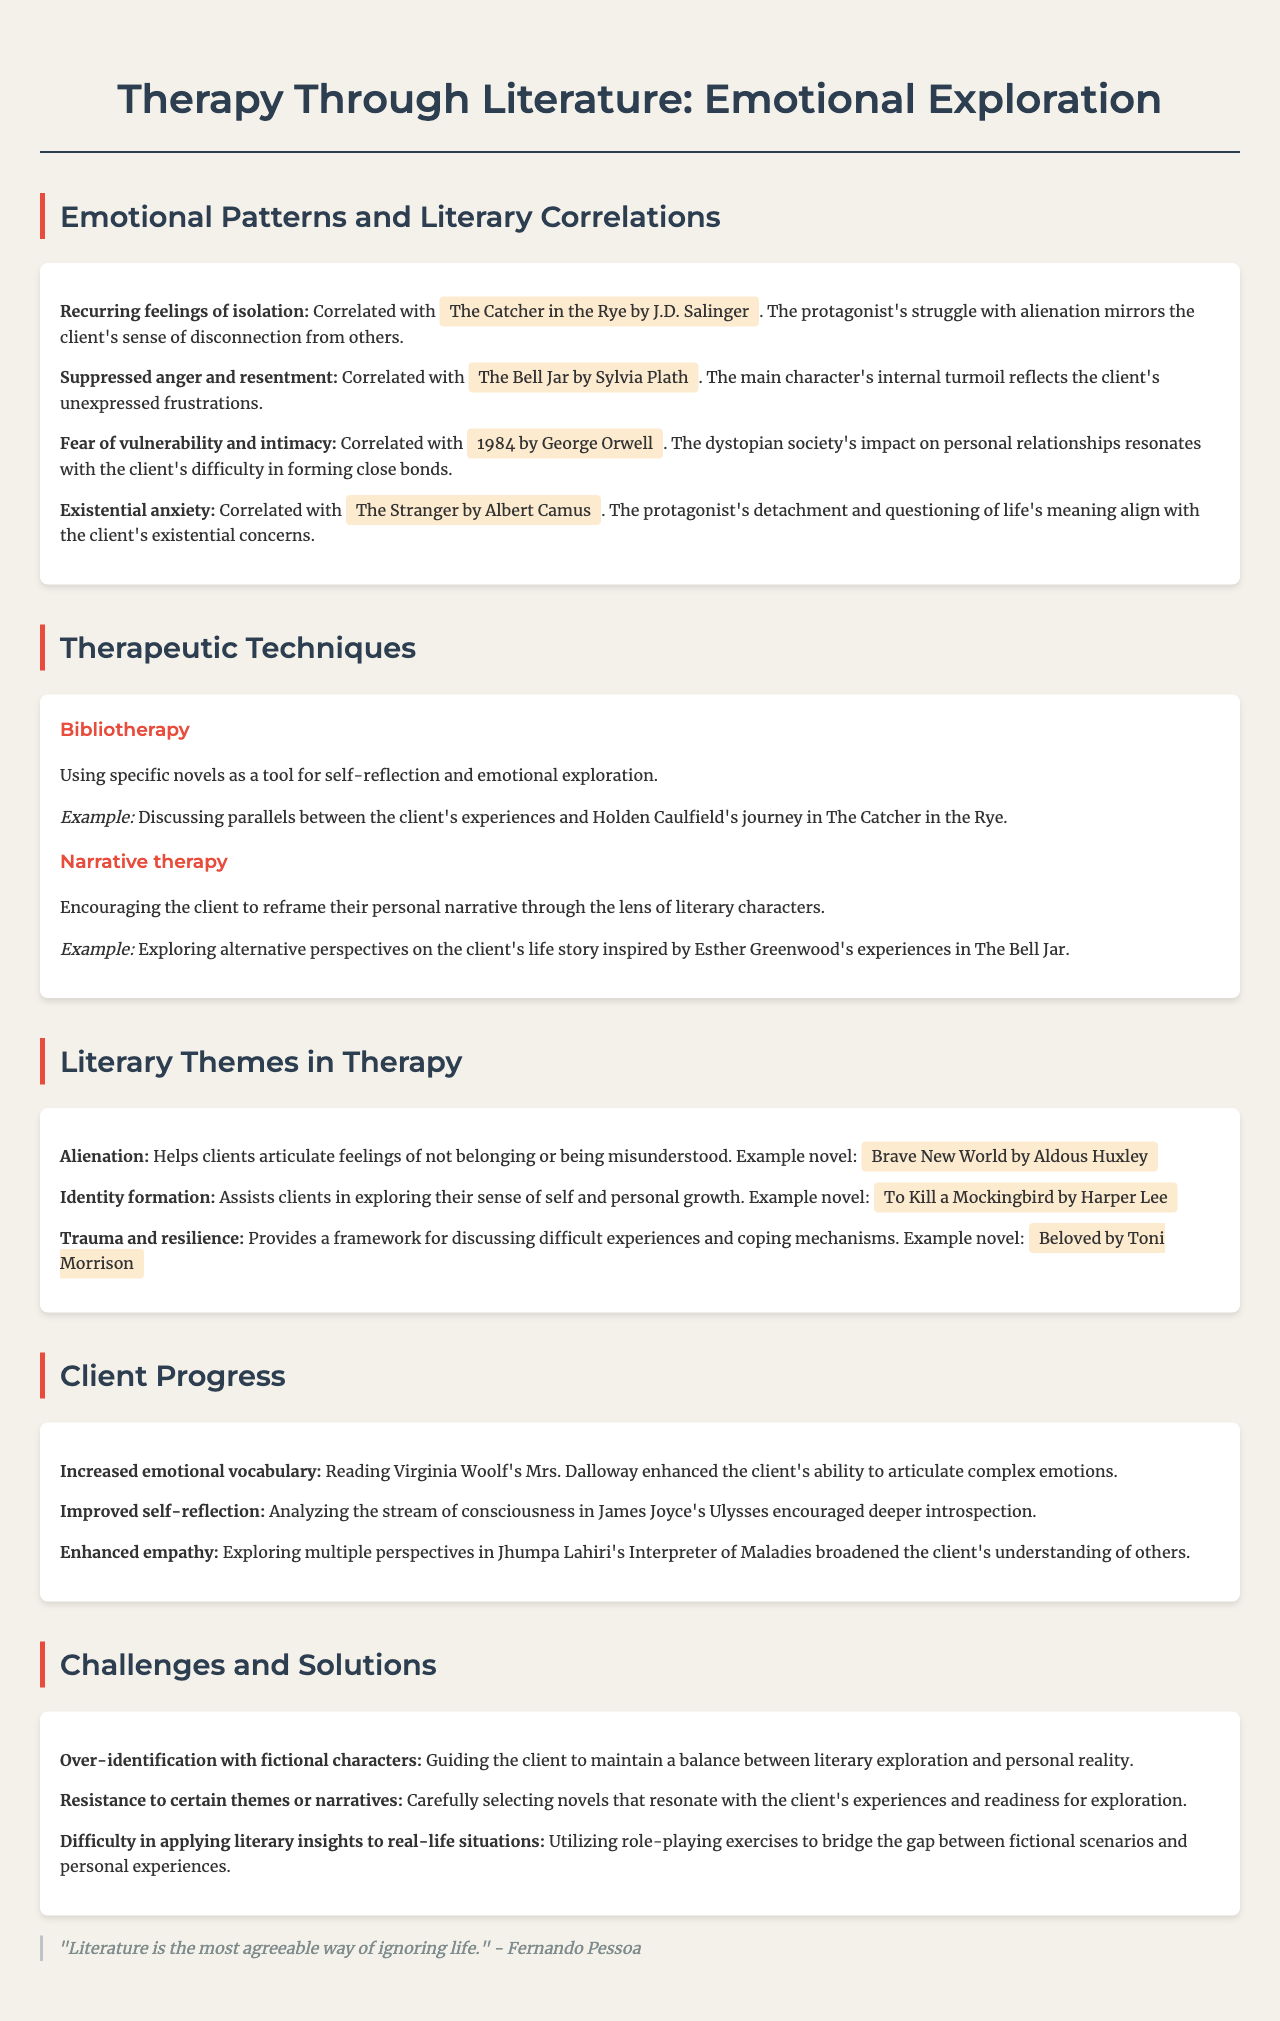what is the first emotional pattern identified in therapy sessions? The first emotional pattern mentioned in the document is "Recurring feelings of isolation."
Answer: Recurring feelings of isolation which novel is correlated with suppressed anger and resentment? The document states that "The Bell Jar by Sylvia Plath" is correlated with this emotional pattern.
Answer: The Bell Jar by Sylvia Plath what therapeutic technique uses novels for self-reflection? The technique that uses novels as a tool for self-reflection is called "Bibliotherapy."
Answer: Bibliotherapy how many literary themes are discussed in the document? The document lists three literary themes relevant to therapy.
Answer: 3 which literary work is cited for helping with identity formation? The novel providing assistance in exploring identity formation is "To Kill a Mockingbird by Harper Lee."
Answer: To Kill a Mockingbird by Harper Lee what milestone relates to improved self-reflection? The milestone associated with improved self-reflection mentions "Analyzing the stream of consciousness in James Joyce's Ulysses."
Answer: Analyzing the stream of consciousness in James Joyce's Ulysses what challenge involves client over-identification with characters? The challenge identified in the document is "Over-identification with fictional characters."
Answer: Over-identification with fictional characters how are resistance themes addressed according to the document? The document states that resistance to certain themes is addressed by "Carefully selecting novels that resonate with the client's experiences."
Answer: Carefully selecting novels that resonate with the client's experiences 